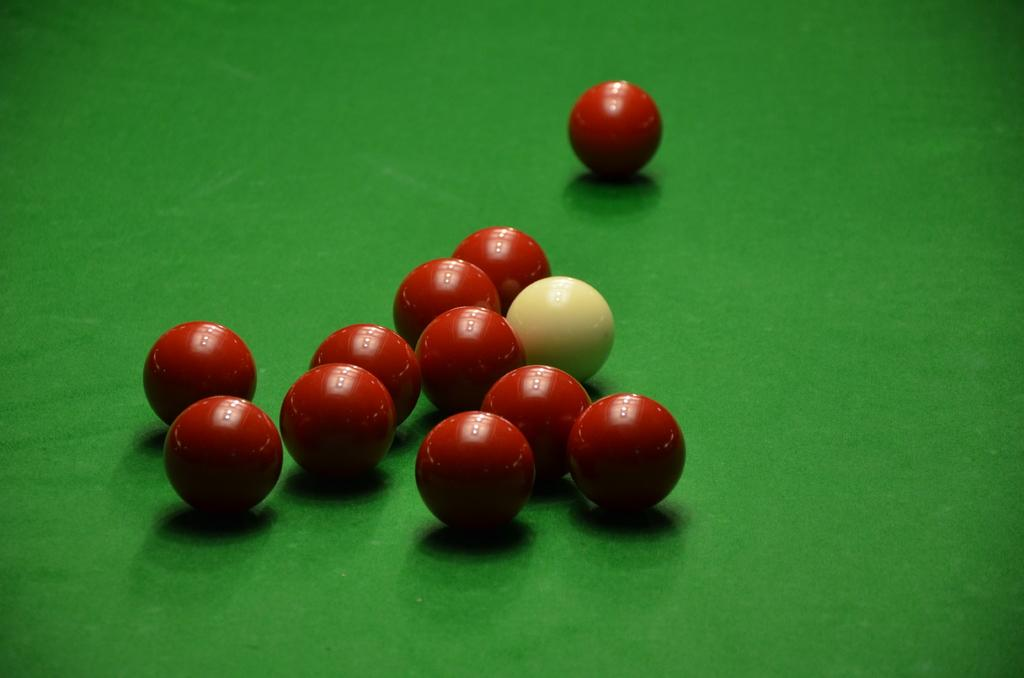What objects are present in the image? There are balls in the image. What colors are the balls? The balls are in red and cream colors. What is the surface on which the balls are placed? The balls are on a green surface. What type of wood can be seen in the image? There is no wood present in the image; it features balls in red and cream colors on a green surface. 